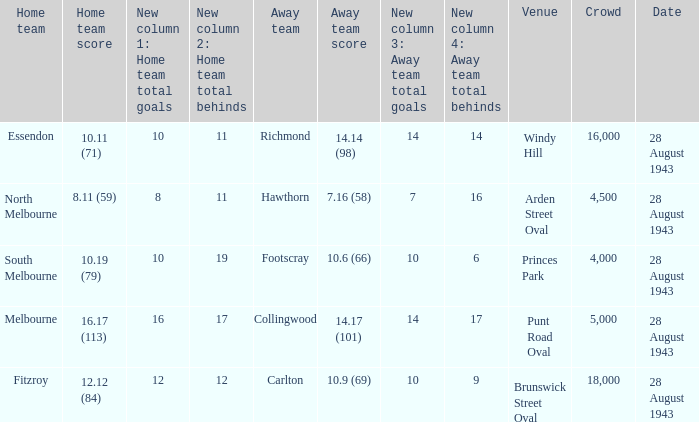In which venue was the contest played with a guest team score of 1 Punt Road Oval. 